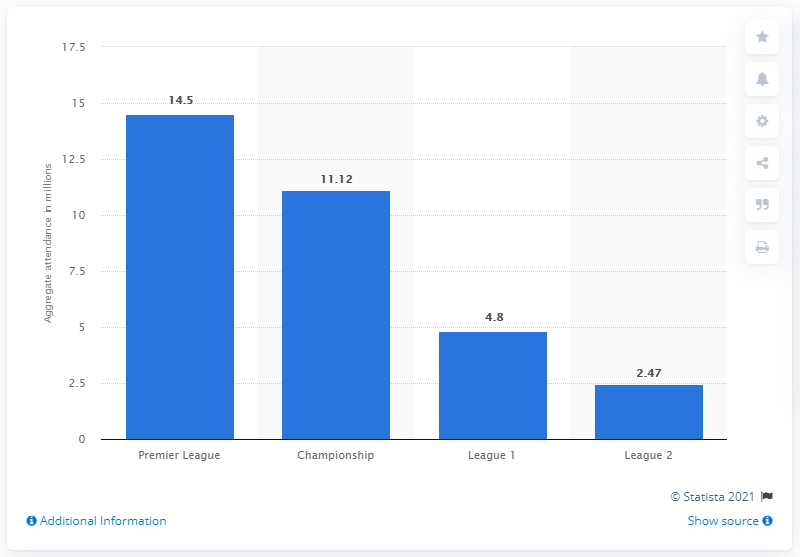Specify some key components in this picture. The Premier League is widely regarded as the most successful football league in the world. It is estimated that in 2019, approximately 14.5 million spectators attended a football match in the United Kingdom. The average number of football attendances in the United Kingdom (UK) in 2019 for the Premier League and Championship leagues was 12,810. In 2019, the number of football attendances in the United Kingdom (UK) for the Premier League was 14.5. 